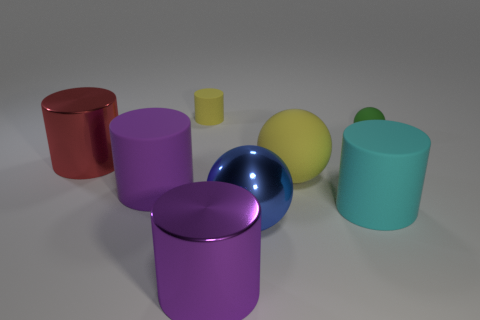Are there any other things of the same color as the metallic ball? After examining the image, it appears that none of the other objects share the exact same hue as the metallic blue ball. However, they exhibit a variety of different colors, suggesting a diverse color palette is present. 